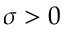Convert formula to latex. <formula><loc_0><loc_0><loc_500><loc_500>\sigma > 0</formula> 